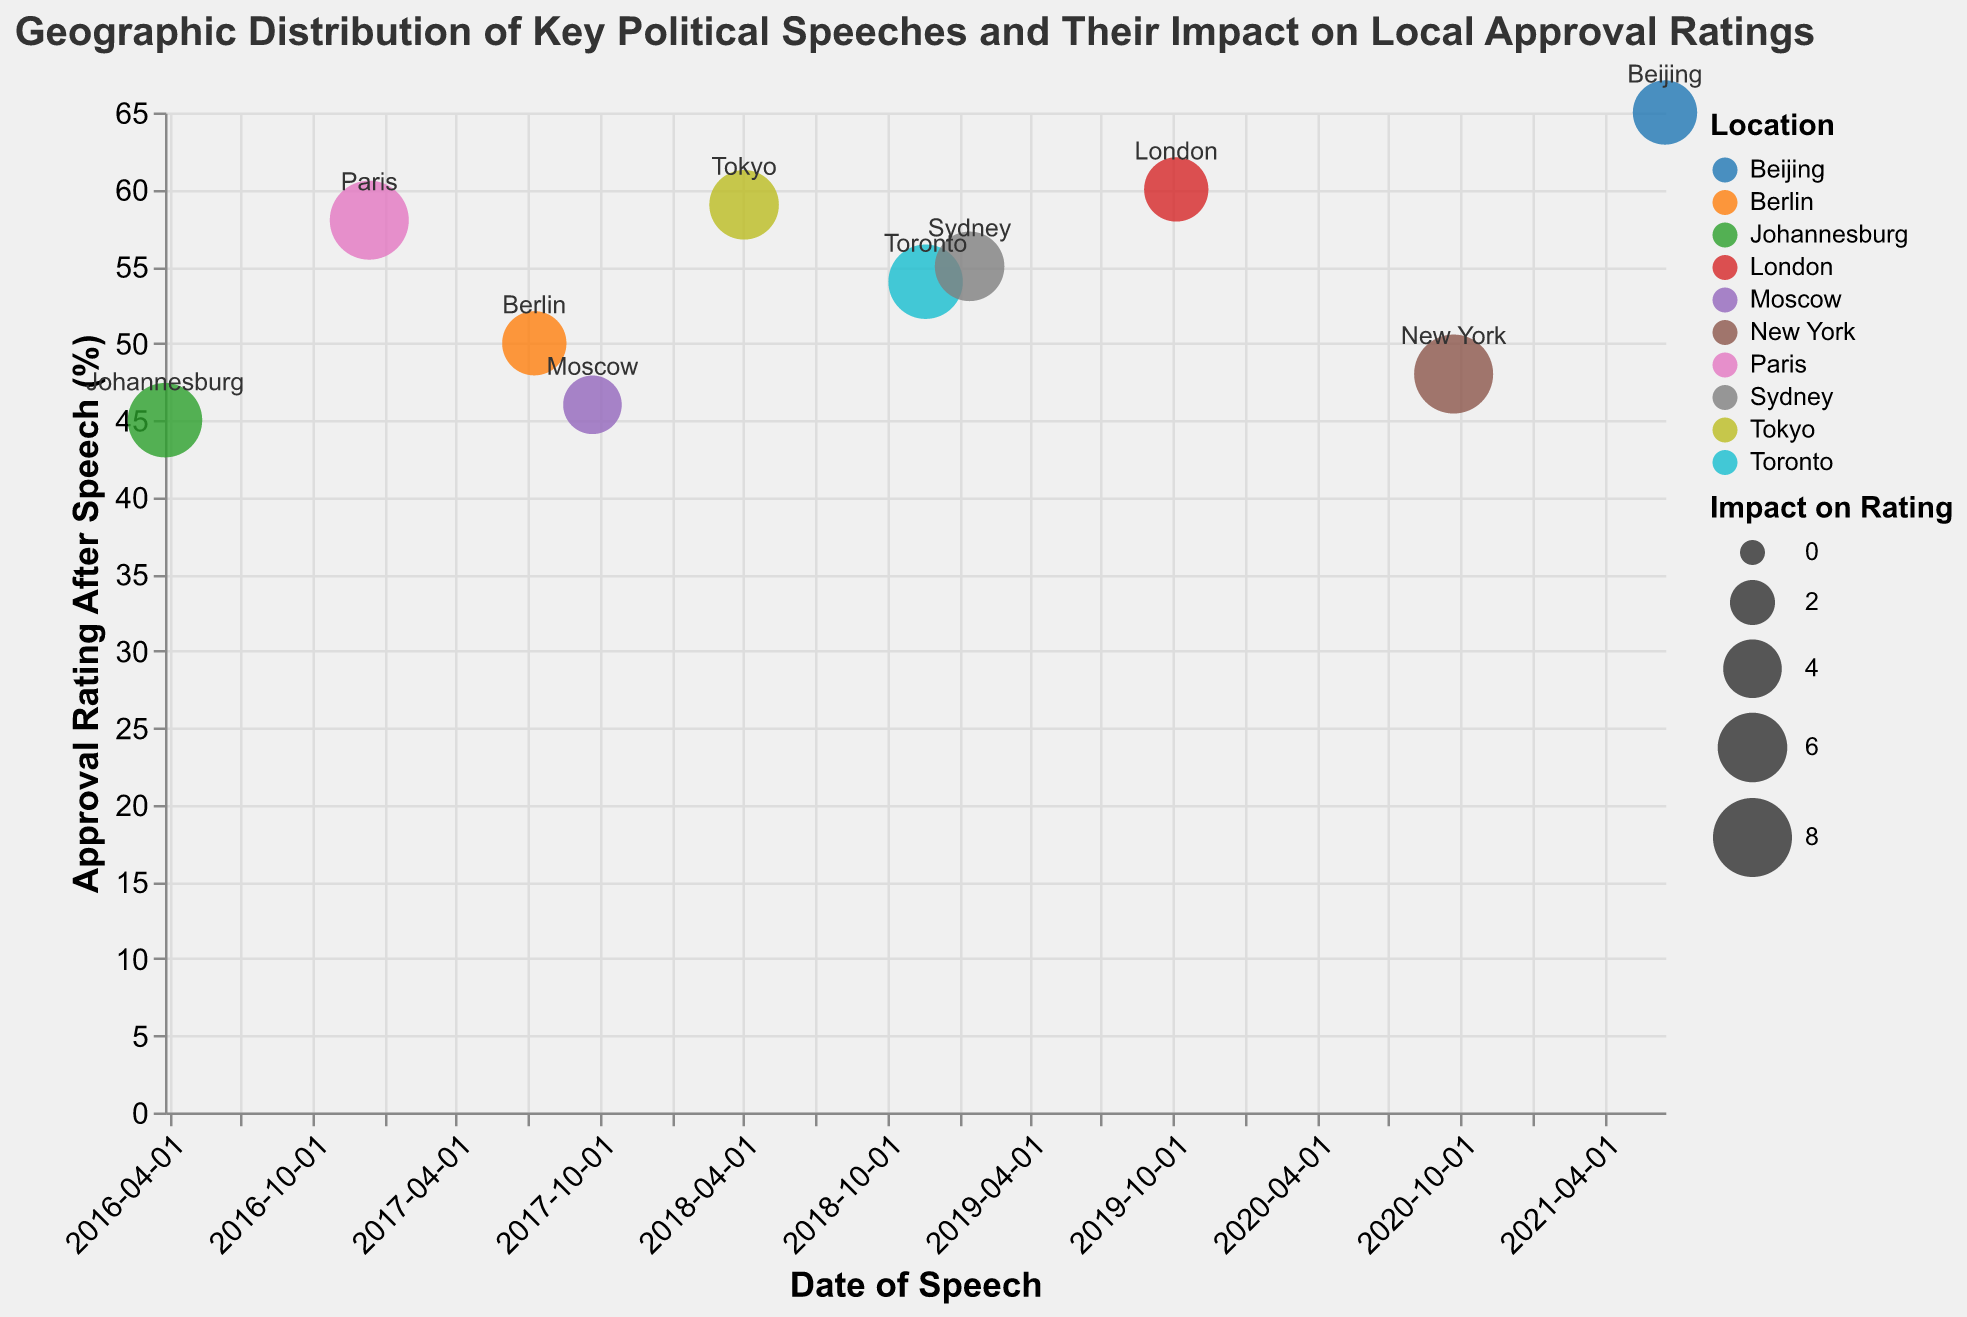What is the title of the figure? The title is typically found at the top of the chart and provides an overview of what the visualization represents. In this figure, the title reads "Geographic Distribution of Key Political Speeches and Their Impact on Local Approval Ratings."
Answer: Geographic Distribution of Key Political Speeches and Their Impact on Local Approval Ratings Which location had the highest approval rating after the speech? By examining the vertical axis, which represents "Approval Rating After Speech (%)," and identifying the highest plotted point, we see that Beijing had the highest approval rating after the "Regional Peace Summit Speech" with a rating of 65%.
Answer: Beijing How does the impact on ratings vary across different locations? To answer this, look at the size of the bubbles since the size encodes the "Impact on Rating". Larger bubbles indicate a greater impact. New York, Paris, and Johannesburg have the largest bubbles, indicating an impact of 8, showing these speeches had the highest impact.
Answer: New York, Paris, Johannesburg have the largest impacts What is the average approval rating after speeches across all locations? To find the average, sum the "Approval_Rating_After_Speech" values for all locations, then divide by the number of locations (10). The ratings are: 48, 60, 58, 50, 59, 54, 55, 65, 46, 45. The sum is 540, and the average is 540/10 = 54.
Answer: 54 Which speech had the least impact on local approval ratings and where was it given? The smallest bubble represents the speech with the least impact. By identifying this bubble, we find that the "Energy Sector Development Speech" in Moscow had the smallest impact, with an impact of 4 percentage points.
Answer: Moscow, Energy Sector Development Speech What is the difference in approval rating after the "Climate Agreement Announcement" in Paris and the "Trade Deal Celebration Speech" in Berlin? Locate the approval ratings after both speeches; Paris has 58% and Berlin has 50%. The difference is calculated as 58 - 50 = 8.
Answer: 8 Which location experienced the greatest increase in approval rating due to the speech and what was the title of the speech? To find the greatest increase, look at the bubbles with the largest sizes and their corresponding "Impact_on_Rating" values. New York, with the "UN General Assembly Speech," experienced the greatest increase with an impact of 8 percentage points.
Answer: New York, UN General Assembly Speech How many locations had speeches that resulted in an approval rating increase of 5 percentage points? Count the bubbles with an "Impact_on_Rating" value of 5. These locations are London, Berlin, and Beijing, totaling 3 locations.
Answer: 3 Which speeches had an approval rating before the speech of less than 50% but resulted in an approval rating after the speech above 50%? Identify speeches where the "Approval_Rating_Before_Speech" is below 50, and "Approval_Rating_After_Speech" is above 50: New York (40 to 48), Berlin (45 to 50), Toronto (47 to 54), Sydney (49 to 55), Moscow (42 to 46), Johannesburg (38 to 45). Only Toronto and Sydney meet the criteria.
Answer: Toronto, Sydney 